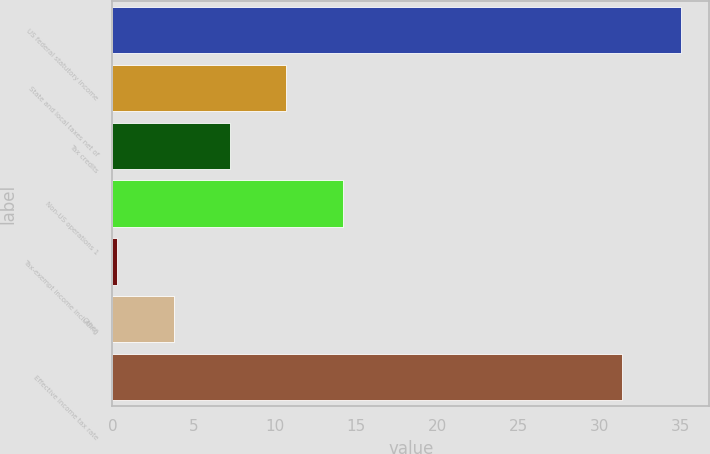<chart> <loc_0><loc_0><loc_500><loc_500><bar_chart><fcel>US federal statutory income<fcel>State and local taxes net of<fcel>Tax credits<fcel>Non-US operations 1<fcel>Tax-exempt income including<fcel>Other<fcel>Effective income tax rate<nl><fcel>35<fcel>10.71<fcel>7.24<fcel>14.18<fcel>0.3<fcel>3.77<fcel>31.4<nl></chart> 